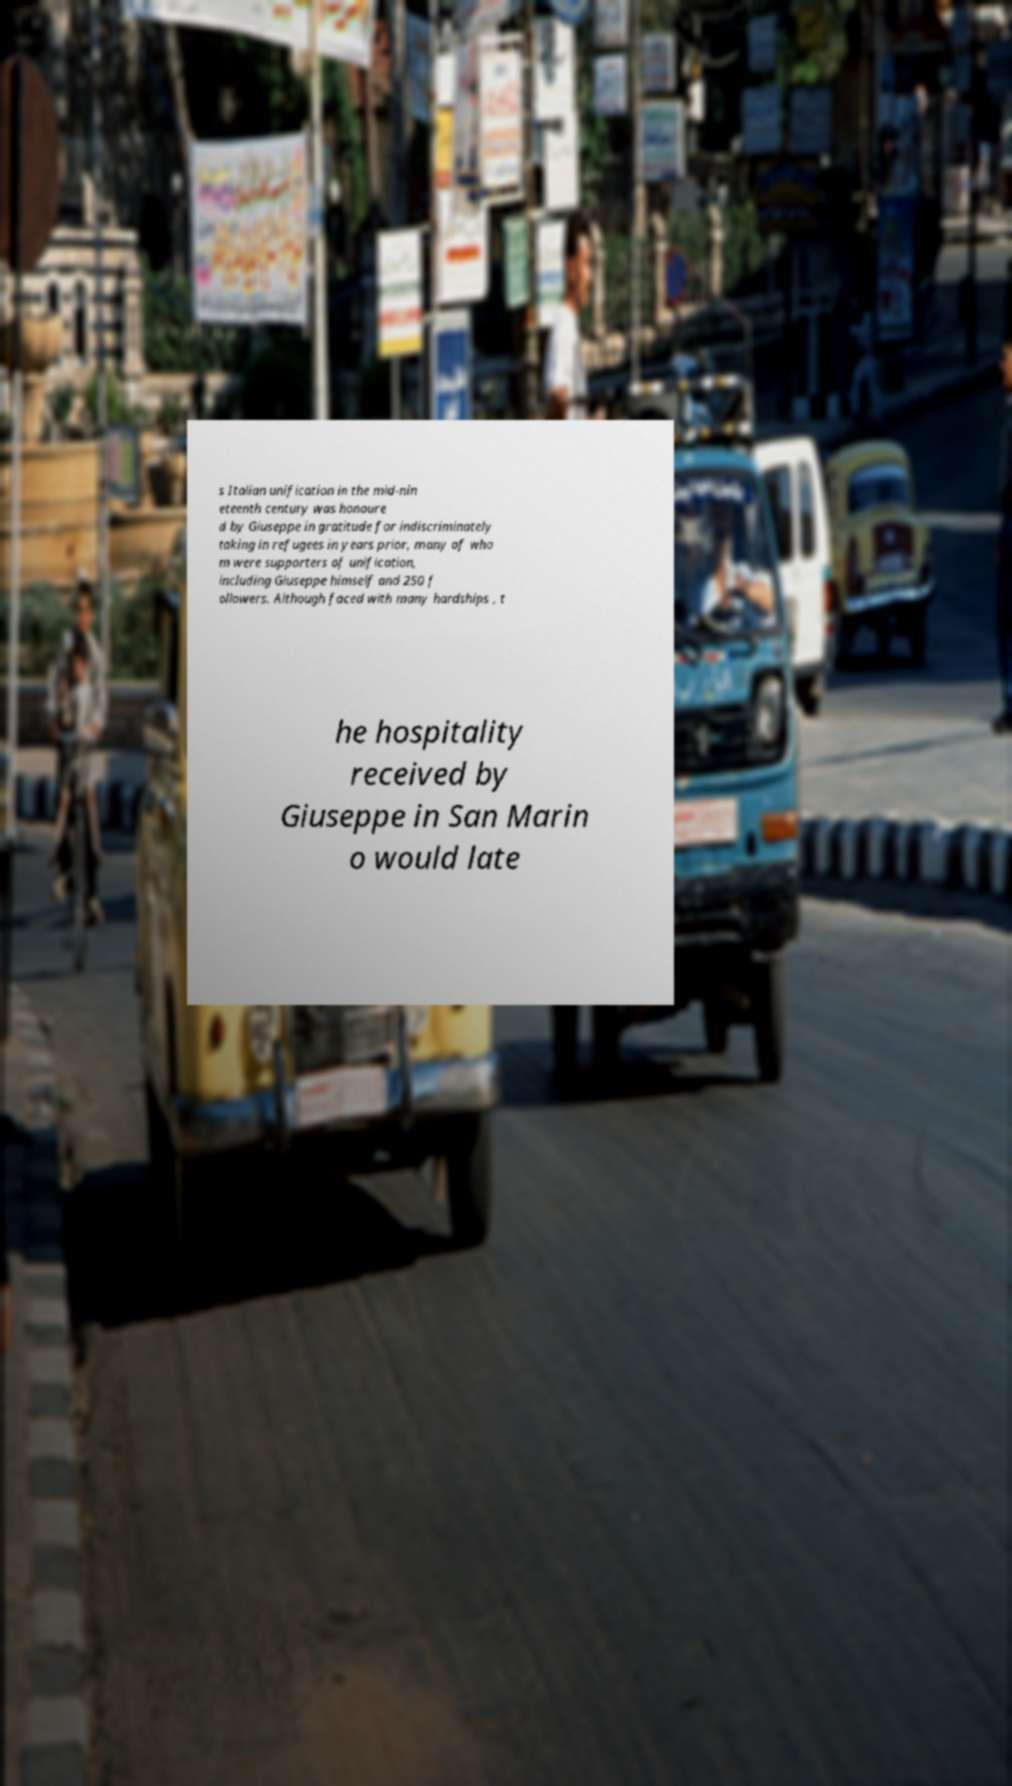I need the written content from this picture converted into text. Can you do that? s Italian unification in the mid-nin eteenth century was honoure d by Giuseppe in gratitude for indiscriminately taking in refugees in years prior, many of who m were supporters of unification, including Giuseppe himself and 250 f ollowers. Although faced with many hardships , t he hospitality received by Giuseppe in San Marin o would late 